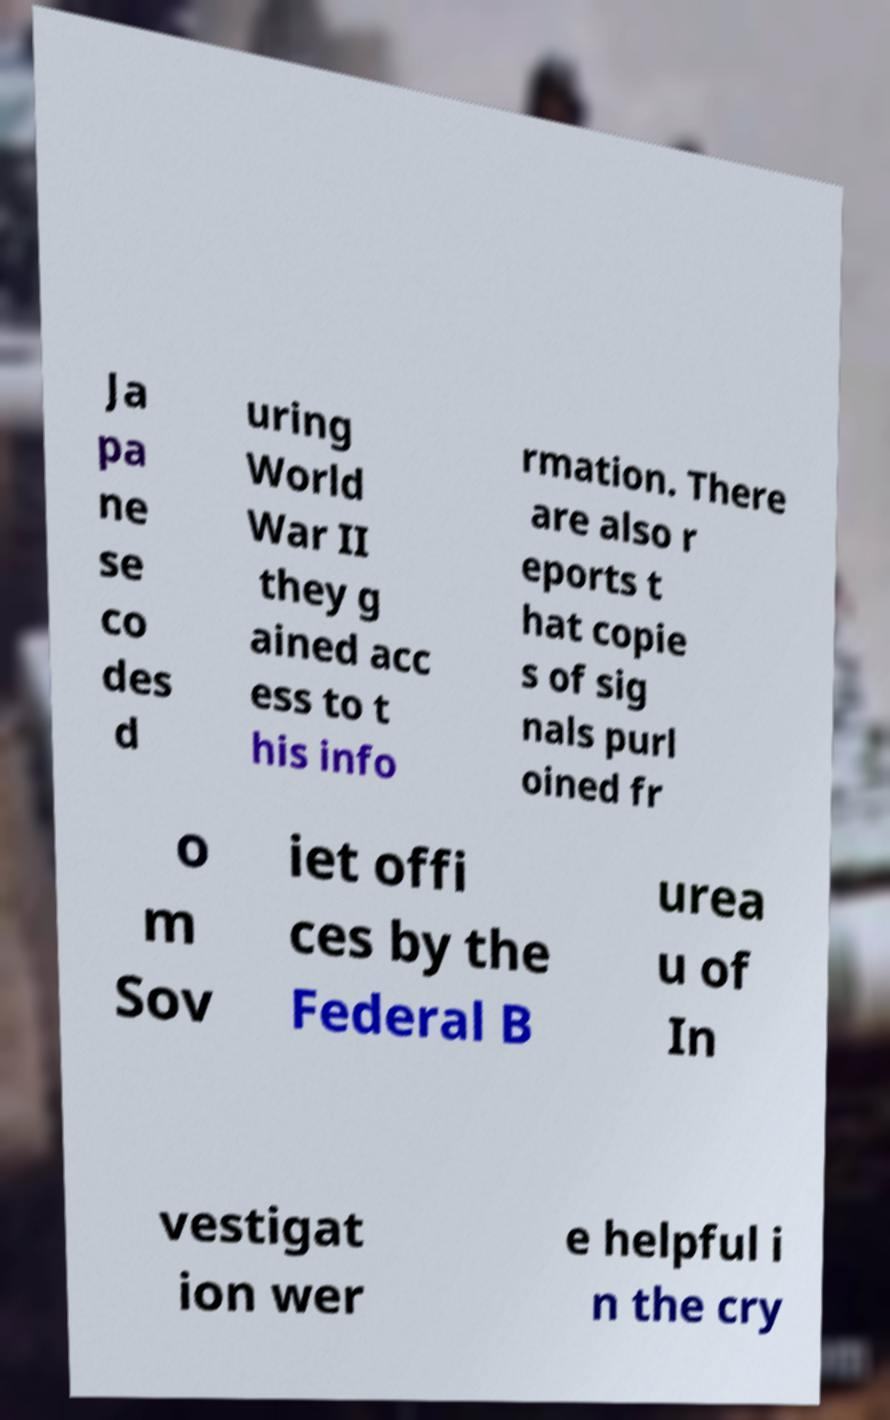What messages or text are displayed in this image? I need them in a readable, typed format. Ja pa ne se co des d uring World War II they g ained acc ess to t his info rmation. There are also r eports t hat copie s of sig nals purl oined fr o m Sov iet offi ces by the Federal B urea u of In vestigat ion wer e helpful i n the cry 